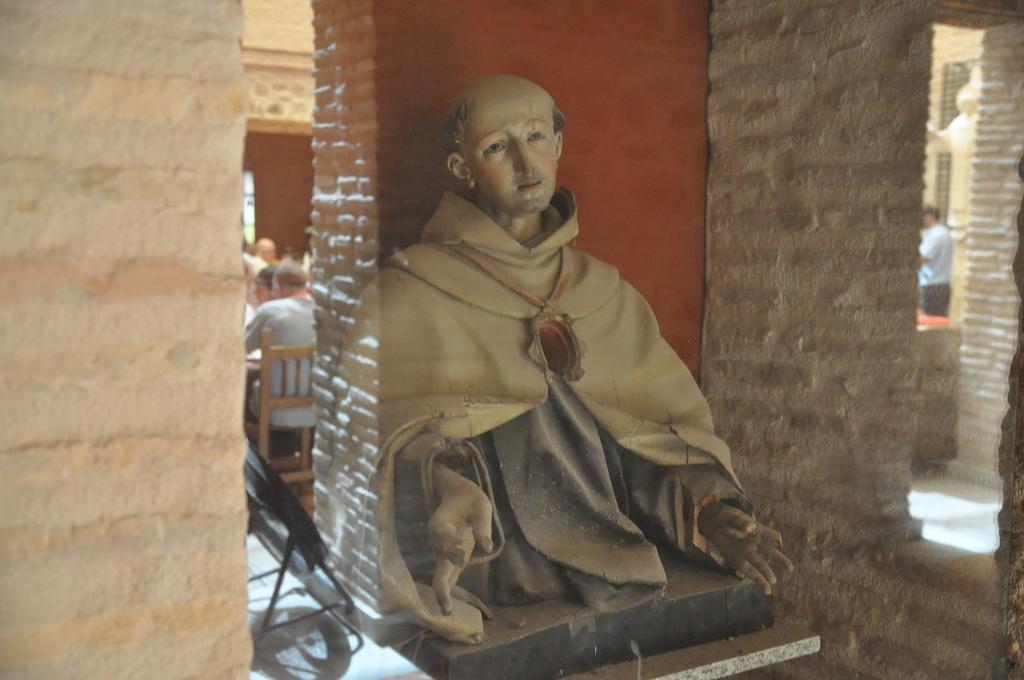How would you summarize this image in a sentence or two? In this image there is a statue behind the glass. Behind the statue there is a wall. Behind the wall there are few persons sitting on the chairs. Right side a person is standing. Beside to him there is a statue. 